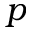<formula> <loc_0><loc_0><loc_500><loc_500>p</formula> 